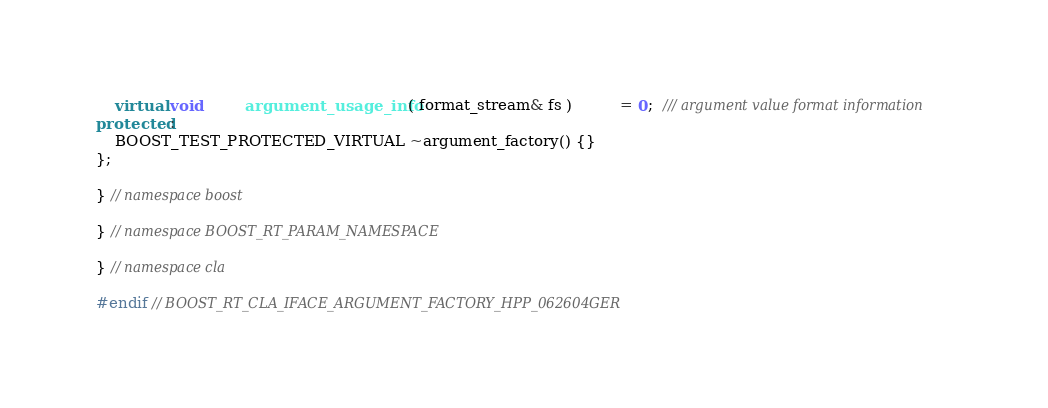Convert code to text. <code><loc_0><loc_0><loc_500><loc_500><_C++_>    virtual void         argument_usage_info( format_stream& fs )          = 0;  /// argument value format information
protected:
    BOOST_TEST_PROTECTED_VIRTUAL ~argument_factory() {}
};

} // namespace boost

} // namespace BOOST_RT_PARAM_NAMESPACE

} // namespace cla

#endif // BOOST_RT_CLA_IFACE_ARGUMENT_FACTORY_HPP_062604GER
</code> 